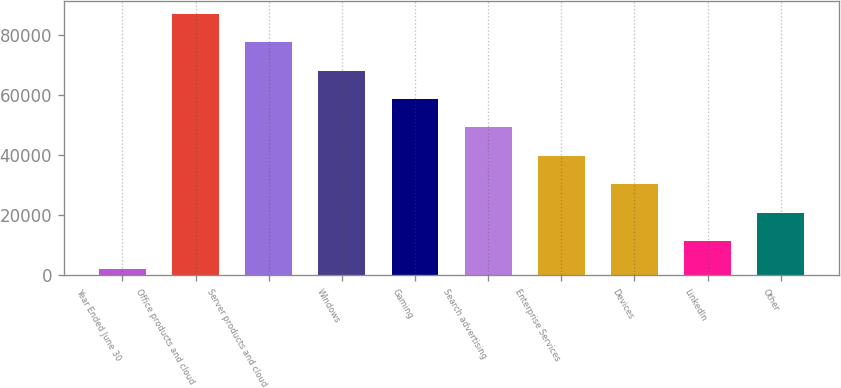Convert chart to OTSL. <chart><loc_0><loc_0><loc_500><loc_500><bar_chart><fcel>Year Ended June 30<fcel>Office products and cloud<fcel>Server products and cloud<fcel>Windows<fcel>Gaming<fcel>Search advertising<fcel>Enterprise Services<fcel>Devices<fcel>LinkedIn<fcel>Other<nl><fcel>2017<fcel>87115.6<fcel>77660.2<fcel>68204.8<fcel>58749.4<fcel>49294<fcel>39838.6<fcel>30383.2<fcel>11472.4<fcel>20927.8<nl></chart> 